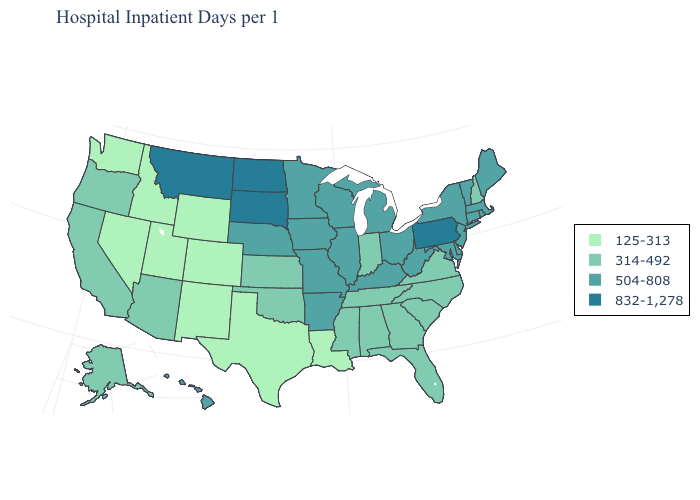Does the first symbol in the legend represent the smallest category?
Quick response, please. Yes. What is the value of Hawaii?
Answer briefly. 504-808. Name the states that have a value in the range 314-492?
Write a very short answer. Alabama, Alaska, Arizona, California, Florida, Georgia, Indiana, Kansas, Mississippi, New Hampshire, North Carolina, Oklahoma, Oregon, South Carolina, Tennessee, Virginia. Name the states that have a value in the range 832-1,278?
Write a very short answer. Montana, North Dakota, Pennsylvania, South Dakota. Name the states that have a value in the range 314-492?
Short answer required. Alabama, Alaska, Arizona, California, Florida, Georgia, Indiana, Kansas, Mississippi, New Hampshire, North Carolina, Oklahoma, Oregon, South Carolina, Tennessee, Virginia. What is the value of Hawaii?
Be succinct. 504-808. Does North Dakota have the highest value in the USA?
Answer briefly. Yes. What is the highest value in the Northeast ?
Write a very short answer. 832-1,278. Which states have the highest value in the USA?
Quick response, please. Montana, North Dakota, Pennsylvania, South Dakota. Name the states that have a value in the range 314-492?
Write a very short answer. Alabama, Alaska, Arizona, California, Florida, Georgia, Indiana, Kansas, Mississippi, New Hampshire, North Carolina, Oklahoma, Oregon, South Carolina, Tennessee, Virginia. What is the lowest value in the USA?
Answer briefly. 125-313. Does New Hampshire have the lowest value in the USA?
Answer briefly. No. Name the states that have a value in the range 125-313?
Quick response, please. Colorado, Idaho, Louisiana, Nevada, New Mexico, Texas, Utah, Washington, Wyoming. Name the states that have a value in the range 125-313?
Answer briefly. Colorado, Idaho, Louisiana, Nevada, New Mexico, Texas, Utah, Washington, Wyoming. Does New Mexico have the lowest value in the USA?
Keep it brief. Yes. 